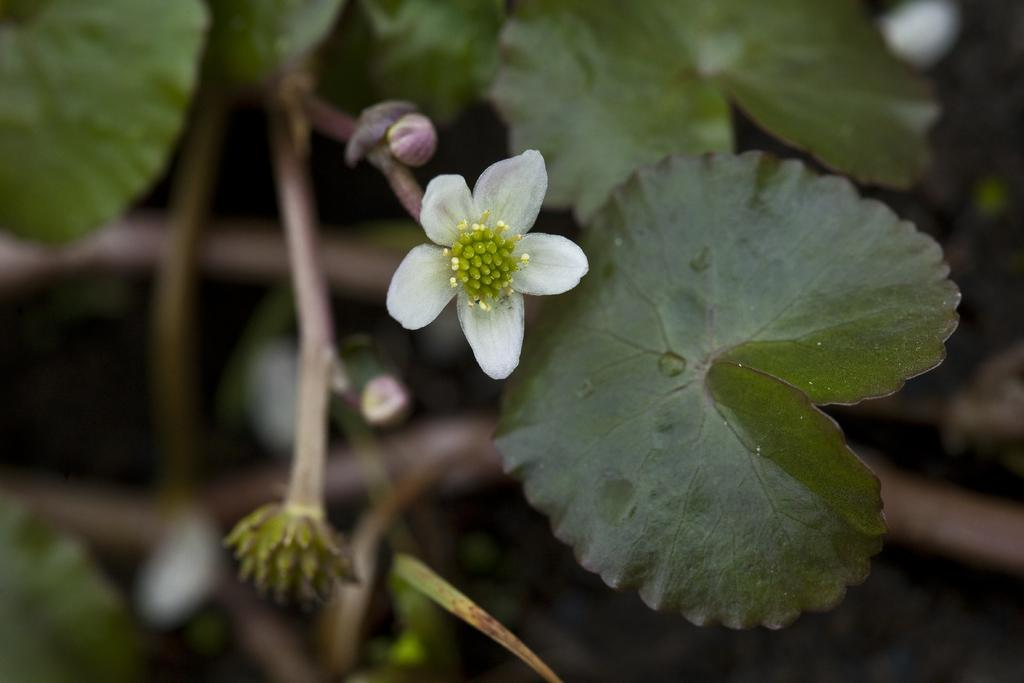What is present in the image? There is a plant in the image. What specific feature of the plant can be observed? The plant has a flower. What color is the flower? The flower is white. Can you describe the background of the image? The background of the image is blurred. Are there any ants crawling on the flower in the image? There is no mention of ants in the image, so we cannot determine if they are present or not. What type of zephyr can be seen blowing through the image? There is no mention of a zephyr in the image, so we cannot determine if it is present or not. 